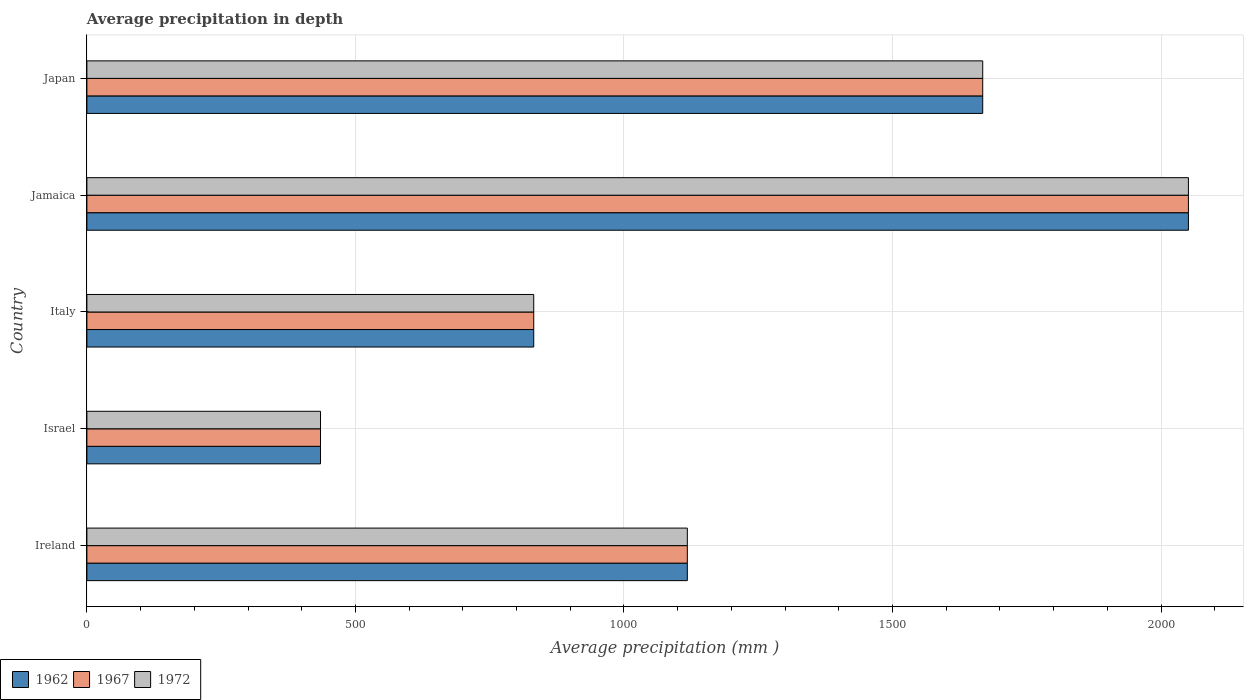How many different coloured bars are there?
Your answer should be compact. 3. Are the number of bars per tick equal to the number of legend labels?
Ensure brevity in your answer.  Yes. How many bars are there on the 2nd tick from the top?
Your response must be concise. 3. What is the label of the 5th group of bars from the top?
Give a very brief answer. Ireland. In how many cases, is the number of bars for a given country not equal to the number of legend labels?
Provide a short and direct response. 0. What is the average precipitation in 1972 in Jamaica?
Your answer should be very brief. 2051. Across all countries, what is the maximum average precipitation in 1962?
Your answer should be very brief. 2051. Across all countries, what is the minimum average precipitation in 1972?
Your answer should be compact. 435. In which country was the average precipitation in 1972 maximum?
Make the answer very short. Jamaica. In which country was the average precipitation in 1967 minimum?
Keep it short and to the point. Israel. What is the total average precipitation in 1967 in the graph?
Keep it short and to the point. 6104. What is the difference between the average precipitation in 1962 in Jamaica and that in Japan?
Your answer should be compact. 383. What is the difference between the average precipitation in 1962 in Italy and the average precipitation in 1967 in Jamaica?
Provide a succinct answer. -1219. What is the average average precipitation in 1967 per country?
Your answer should be very brief. 1220.8. What is the difference between the average precipitation in 1967 and average precipitation in 1972 in Ireland?
Your answer should be very brief. 0. In how many countries, is the average precipitation in 1972 greater than 2000 mm?
Offer a very short reply. 1. What is the ratio of the average precipitation in 1962 in Ireland to that in Jamaica?
Your answer should be compact. 0.55. Is the difference between the average precipitation in 1967 in Ireland and Japan greater than the difference between the average precipitation in 1972 in Ireland and Japan?
Offer a very short reply. No. What is the difference between the highest and the second highest average precipitation in 1962?
Keep it short and to the point. 383. What is the difference between the highest and the lowest average precipitation in 1967?
Your answer should be compact. 1616. What does the 1st bar from the bottom in Italy represents?
Provide a succinct answer. 1962. Is it the case that in every country, the sum of the average precipitation in 1967 and average precipitation in 1962 is greater than the average precipitation in 1972?
Keep it short and to the point. Yes. How many bars are there?
Keep it short and to the point. 15. How many countries are there in the graph?
Ensure brevity in your answer.  5. Are the values on the major ticks of X-axis written in scientific E-notation?
Provide a succinct answer. No. Does the graph contain any zero values?
Provide a succinct answer. No. Does the graph contain grids?
Keep it short and to the point. Yes. Where does the legend appear in the graph?
Provide a short and direct response. Bottom left. What is the title of the graph?
Your answer should be very brief. Average precipitation in depth. What is the label or title of the X-axis?
Your response must be concise. Average precipitation (mm ). What is the Average precipitation (mm ) in 1962 in Ireland?
Provide a short and direct response. 1118. What is the Average precipitation (mm ) of 1967 in Ireland?
Offer a terse response. 1118. What is the Average precipitation (mm ) of 1972 in Ireland?
Keep it short and to the point. 1118. What is the Average precipitation (mm ) in 1962 in Israel?
Offer a very short reply. 435. What is the Average precipitation (mm ) of 1967 in Israel?
Give a very brief answer. 435. What is the Average precipitation (mm ) of 1972 in Israel?
Your answer should be compact. 435. What is the Average precipitation (mm ) of 1962 in Italy?
Provide a succinct answer. 832. What is the Average precipitation (mm ) of 1967 in Italy?
Ensure brevity in your answer.  832. What is the Average precipitation (mm ) of 1972 in Italy?
Your response must be concise. 832. What is the Average precipitation (mm ) in 1962 in Jamaica?
Offer a terse response. 2051. What is the Average precipitation (mm ) in 1967 in Jamaica?
Offer a very short reply. 2051. What is the Average precipitation (mm ) of 1972 in Jamaica?
Your answer should be very brief. 2051. What is the Average precipitation (mm ) in 1962 in Japan?
Offer a very short reply. 1668. What is the Average precipitation (mm ) of 1967 in Japan?
Make the answer very short. 1668. What is the Average precipitation (mm ) of 1972 in Japan?
Your response must be concise. 1668. Across all countries, what is the maximum Average precipitation (mm ) in 1962?
Ensure brevity in your answer.  2051. Across all countries, what is the maximum Average precipitation (mm ) of 1967?
Give a very brief answer. 2051. Across all countries, what is the maximum Average precipitation (mm ) in 1972?
Your response must be concise. 2051. Across all countries, what is the minimum Average precipitation (mm ) of 1962?
Give a very brief answer. 435. Across all countries, what is the minimum Average precipitation (mm ) of 1967?
Provide a short and direct response. 435. Across all countries, what is the minimum Average precipitation (mm ) in 1972?
Provide a short and direct response. 435. What is the total Average precipitation (mm ) in 1962 in the graph?
Your response must be concise. 6104. What is the total Average precipitation (mm ) of 1967 in the graph?
Provide a short and direct response. 6104. What is the total Average precipitation (mm ) in 1972 in the graph?
Offer a terse response. 6104. What is the difference between the Average precipitation (mm ) in 1962 in Ireland and that in Israel?
Provide a short and direct response. 683. What is the difference between the Average precipitation (mm ) of 1967 in Ireland and that in Israel?
Make the answer very short. 683. What is the difference between the Average precipitation (mm ) in 1972 in Ireland and that in Israel?
Provide a succinct answer. 683. What is the difference between the Average precipitation (mm ) in 1962 in Ireland and that in Italy?
Your answer should be compact. 286. What is the difference between the Average precipitation (mm ) in 1967 in Ireland and that in Italy?
Provide a succinct answer. 286. What is the difference between the Average precipitation (mm ) in 1972 in Ireland and that in Italy?
Your answer should be very brief. 286. What is the difference between the Average precipitation (mm ) in 1962 in Ireland and that in Jamaica?
Offer a very short reply. -933. What is the difference between the Average precipitation (mm ) in 1967 in Ireland and that in Jamaica?
Make the answer very short. -933. What is the difference between the Average precipitation (mm ) in 1972 in Ireland and that in Jamaica?
Ensure brevity in your answer.  -933. What is the difference between the Average precipitation (mm ) of 1962 in Ireland and that in Japan?
Make the answer very short. -550. What is the difference between the Average precipitation (mm ) of 1967 in Ireland and that in Japan?
Make the answer very short. -550. What is the difference between the Average precipitation (mm ) of 1972 in Ireland and that in Japan?
Keep it short and to the point. -550. What is the difference between the Average precipitation (mm ) of 1962 in Israel and that in Italy?
Provide a short and direct response. -397. What is the difference between the Average precipitation (mm ) of 1967 in Israel and that in Italy?
Your response must be concise. -397. What is the difference between the Average precipitation (mm ) of 1972 in Israel and that in Italy?
Provide a short and direct response. -397. What is the difference between the Average precipitation (mm ) of 1962 in Israel and that in Jamaica?
Ensure brevity in your answer.  -1616. What is the difference between the Average precipitation (mm ) in 1967 in Israel and that in Jamaica?
Your answer should be very brief. -1616. What is the difference between the Average precipitation (mm ) of 1972 in Israel and that in Jamaica?
Offer a terse response. -1616. What is the difference between the Average precipitation (mm ) of 1962 in Israel and that in Japan?
Keep it short and to the point. -1233. What is the difference between the Average precipitation (mm ) of 1967 in Israel and that in Japan?
Your answer should be compact. -1233. What is the difference between the Average precipitation (mm ) in 1972 in Israel and that in Japan?
Make the answer very short. -1233. What is the difference between the Average precipitation (mm ) of 1962 in Italy and that in Jamaica?
Offer a terse response. -1219. What is the difference between the Average precipitation (mm ) in 1967 in Italy and that in Jamaica?
Offer a very short reply. -1219. What is the difference between the Average precipitation (mm ) in 1972 in Italy and that in Jamaica?
Keep it short and to the point. -1219. What is the difference between the Average precipitation (mm ) in 1962 in Italy and that in Japan?
Keep it short and to the point. -836. What is the difference between the Average precipitation (mm ) in 1967 in Italy and that in Japan?
Your answer should be compact. -836. What is the difference between the Average precipitation (mm ) of 1972 in Italy and that in Japan?
Give a very brief answer. -836. What is the difference between the Average precipitation (mm ) in 1962 in Jamaica and that in Japan?
Give a very brief answer. 383. What is the difference between the Average precipitation (mm ) in 1967 in Jamaica and that in Japan?
Give a very brief answer. 383. What is the difference between the Average precipitation (mm ) in 1972 in Jamaica and that in Japan?
Keep it short and to the point. 383. What is the difference between the Average precipitation (mm ) in 1962 in Ireland and the Average precipitation (mm ) in 1967 in Israel?
Provide a succinct answer. 683. What is the difference between the Average precipitation (mm ) in 1962 in Ireland and the Average precipitation (mm ) in 1972 in Israel?
Ensure brevity in your answer.  683. What is the difference between the Average precipitation (mm ) of 1967 in Ireland and the Average precipitation (mm ) of 1972 in Israel?
Give a very brief answer. 683. What is the difference between the Average precipitation (mm ) in 1962 in Ireland and the Average precipitation (mm ) in 1967 in Italy?
Make the answer very short. 286. What is the difference between the Average precipitation (mm ) of 1962 in Ireland and the Average precipitation (mm ) of 1972 in Italy?
Give a very brief answer. 286. What is the difference between the Average precipitation (mm ) in 1967 in Ireland and the Average precipitation (mm ) in 1972 in Italy?
Ensure brevity in your answer.  286. What is the difference between the Average precipitation (mm ) in 1962 in Ireland and the Average precipitation (mm ) in 1967 in Jamaica?
Your answer should be compact. -933. What is the difference between the Average precipitation (mm ) in 1962 in Ireland and the Average precipitation (mm ) in 1972 in Jamaica?
Ensure brevity in your answer.  -933. What is the difference between the Average precipitation (mm ) of 1967 in Ireland and the Average precipitation (mm ) of 1972 in Jamaica?
Offer a terse response. -933. What is the difference between the Average precipitation (mm ) in 1962 in Ireland and the Average precipitation (mm ) in 1967 in Japan?
Your answer should be very brief. -550. What is the difference between the Average precipitation (mm ) of 1962 in Ireland and the Average precipitation (mm ) of 1972 in Japan?
Provide a short and direct response. -550. What is the difference between the Average precipitation (mm ) of 1967 in Ireland and the Average precipitation (mm ) of 1972 in Japan?
Provide a short and direct response. -550. What is the difference between the Average precipitation (mm ) in 1962 in Israel and the Average precipitation (mm ) in 1967 in Italy?
Keep it short and to the point. -397. What is the difference between the Average precipitation (mm ) in 1962 in Israel and the Average precipitation (mm ) in 1972 in Italy?
Make the answer very short. -397. What is the difference between the Average precipitation (mm ) of 1967 in Israel and the Average precipitation (mm ) of 1972 in Italy?
Give a very brief answer. -397. What is the difference between the Average precipitation (mm ) of 1962 in Israel and the Average precipitation (mm ) of 1967 in Jamaica?
Ensure brevity in your answer.  -1616. What is the difference between the Average precipitation (mm ) in 1962 in Israel and the Average precipitation (mm ) in 1972 in Jamaica?
Keep it short and to the point. -1616. What is the difference between the Average precipitation (mm ) of 1967 in Israel and the Average precipitation (mm ) of 1972 in Jamaica?
Provide a short and direct response. -1616. What is the difference between the Average precipitation (mm ) in 1962 in Israel and the Average precipitation (mm ) in 1967 in Japan?
Make the answer very short. -1233. What is the difference between the Average precipitation (mm ) of 1962 in Israel and the Average precipitation (mm ) of 1972 in Japan?
Provide a short and direct response. -1233. What is the difference between the Average precipitation (mm ) of 1967 in Israel and the Average precipitation (mm ) of 1972 in Japan?
Give a very brief answer. -1233. What is the difference between the Average precipitation (mm ) in 1962 in Italy and the Average precipitation (mm ) in 1967 in Jamaica?
Offer a terse response. -1219. What is the difference between the Average precipitation (mm ) of 1962 in Italy and the Average precipitation (mm ) of 1972 in Jamaica?
Your response must be concise. -1219. What is the difference between the Average precipitation (mm ) of 1967 in Italy and the Average precipitation (mm ) of 1972 in Jamaica?
Offer a very short reply. -1219. What is the difference between the Average precipitation (mm ) of 1962 in Italy and the Average precipitation (mm ) of 1967 in Japan?
Provide a short and direct response. -836. What is the difference between the Average precipitation (mm ) of 1962 in Italy and the Average precipitation (mm ) of 1972 in Japan?
Provide a short and direct response. -836. What is the difference between the Average precipitation (mm ) of 1967 in Italy and the Average precipitation (mm ) of 1972 in Japan?
Your answer should be very brief. -836. What is the difference between the Average precipitation (mm ) of 1962 in Jamaica and the Average precipitation (mm ) of 1967 in Japan?
Your response must be concise. 383. What is the difference between the Average precipitation (mm ) in 1962 in Jamaica and the Average precipitation (mm ) in 1972 in Japan?
Ensure brevity in your answer.  383. What is the difference between the Average precipitation (mm ) in 1967 in Jamaica and the Average precipitation (mm ) in 1972 in Japan?
Ensure brevity in your answer.  383. What is the average Average precipitation (mm ) of 1962 per country?
Your answer should be very brief. 1220.8. What is the average Average precipitation (mm ) in 1967 per country?
Make the answer very short. 1220.8. What is the average Average precipitation (mm ) in 1972 per country?
Provide a short and direct response. 1220.8. What is the difference between the Average precipitation (mm ) in 1962 and Average precipitation (mm ) in 1972 in Ireland?
Keep it short and to the point. 0. What is the difference between the Average precipitation (mm ) in 1962 and Average precipitation (mm ) in 1967 in Italy?
Ensure brevity in your answer.  0. What is the difference between the Average precipitation (mm ) of 1967 and Average precipitation (mm ) of 1972 in Italy?
Your answer should be compact. 0. What is the difference between the Average precipitation (mm ) of 1962 and Average precipitation (mm ) of 1967 in Jamaica?
Offer a terse response. 0. What is the difference between the Average precipitation (mm ) of 1967 and Average precipitation (mm ) of 1972 in Jamaica?
Keep it short and to the point. 0. What is the difference between the Average precipitation (mm ) in 1962 and Average precipitation (mm ) in 1972 in Japan?
Provide a short and direct response. 0. What is the difference between the Average precipitation (mm ) in 1967 and Average precipitation (mm ) in 1972 in Japan?
Provide a short and direct response. 0. What is the ratio of the Average precipitation (mm ) in 1962 in Ireland to that in Israel?
Offer a very short reply. 2.57. What is the ratio of the Average precipitation (mm ) in 1967 in Ireland to that in Israel?
Offer a very short reply. 2.57. What is the ratio of the Average precipitation (mm ) of 1972 in Ireland to that in Israel?
Provide a short and direct response. 2.57. What is the ratio of the Average precipitation (mm ) of 1962 in Ireland to that in Italy?
Your answer should be very brief. 1.34. What is the ratio of the Average precipitation (mm ) of 1967 in Ireland to that in Italy?
Make the answer very short. 1.34. What is the ratio of the Average precipitation (mm ) of 1972 in Ireland to that in Italy?
Your answer should be compact. 1.34. What is the ratio of the Average precipitation (mm ) of 1962 in Ireland to that in Jamaica?
Ensure brevity in your answer.  0.55. What is the ratio of the Average precipitation (mm ) in 1967 in Ireland to that in Jamaica?
Provide a short and direct response. 0.55. What is the ratio of the Average precipitation (mm ) of 1972 in Ireland to that in Jamaica?
Your response must be concise. 0.55. What is the ratio of the Average precipitation (mm ) in 1962 in Ireland to that in Japan?
Your answer should be very brief. 0.67. What is the ratio of the Average precipitation (mm ) in 1967 in Ireland to that in Japan?
Provide a succinct answer. 0.67. What is the ratio of the Average precipitation (mm ) in 1972 in Ireland to that in Japan?
Ensure brevity in your answer.  0.67. What is the ratio of the Average precipitation (mm ) in 1962 in Israel to that in Italy?
Provide a succinct answer. 0.52. What is the ratio of the Average precipitation (mm ) in 1967 in Israel to that in Italy?
Give a very brief answer. 0.52. What is the ratio of the Average precipitation (mm ) of 1972 in Israel to that in Italy?
Your response must be concise. 0.52. What is the ratio of the Average precipitation (mm ) in 1962 in Israel to that in Jamaica?
Provide a succinct answer. 0.21. What is the ratio of the Average precipitation (mm ) in 1967 in Israel to that in Jamaica?
Offer a terse response. 0.21. What is the ratio of the Average precipitation (mm ) of 1972 in Israel to that in Jamaica?
Provide a short and direct response. 0.21. What is the ratio of the Average precipitation (mm ) in 1962 in Israel to that in Japan?
Your answer should be very brief. 0.26. What is the ratio of the Average precipitation (mm ) of 1967 in Israel to that in Japan?
Make the answer very short. 0.26. What is the ratio of the Average precipitation (mm ) of 1972 in Israel to that in Japan?
Keep it short and to the point. 0.26. What is the ratio of the Average precipitation (mm ) of 1962 in Italy to that in Jamaica?
Keep it short and to the point. 0.41. What is the ratio of the Average precipitation (mm ) of 1967 in Italy to that in Jamaica?
Provide a short and direct response. 0.41. What is the ratio of the Average precipitation (mm ) in 1972 in Italy to that in Jamaica?
Keep it short and to the point. 0.41. What is the ratio of the Average precipitation (mm ) in 1962 in Italy to that in Japan?
Provide a short and direct response. 0.5. What is the ratio of the Average precipitation (mm ) in 1967 in Italy to that in Japan?
Your response must be concise. 0.5. What is the ratio of the Average precipitation (mm ) in 1972 in Italy to that in Japan?
Keep it short and to the point. 0.5. What is the ratio of the Average precipitation (mm ) of 1962 in Jamaica to that in Japan?
Ensure brevity in your answer.  1.23. What is the ratio of the Average precipitation (mm ) of 1967 in Jamaica to that in Japan?
Your response must be concise. 1.23. What is the ratio of the Average precipitation (mm ) of 1972 in Jamaica to that in Japan?
Provide a short and direct response. 1.23. What is the difference between the highest and the second highest Average precipitation (mm ) in 1962?
Give a very brief answer. 383. What is the difference between the highest and the second highest Average precipitation (mm ) in 1967?
Keep it short and to the point. 383. What is the difference between the highest and the second highest Average precipitation (mm ) in 1972?
Offer a very short reply. 383. What is the difference between the highest and the lowest Average precipitation (mm ) in 1962?
Offer a very short reply. 1616. What is the difference between the highest and the lowest Average precipitation (mm ) in 1967?
Offer a terse response. 1616. What is the difference between the highest and the lowest Average precipitation (mm ) in 1972?
Your response must be concise. 1616. 